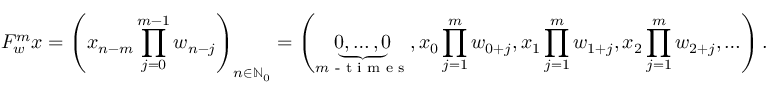Convert formula to latex. <formula><loc_0><loc_0><loc_500><loc_500>F _ { w } ^ { m } x = \left ( x _ { n - m } \prod _ { j = 0 } ^ { m - 1 } w _ { n - j } \right ) _ { n \in \mathbb { N } _ { 0 } } = \left ( \underbrace { 0 , \dots , 0 } _ { m - t i m e s } , x _ { 0 } \prod _ { j = 1 } ^ { m } w _ { 0 + j } , x _ { 1 } \prod _ { j = 1 } ^ { m } w _ { 1 + j } , x _ { 2 } \prod _ { j = 1 } ^ { m } w _ { 2 + j } , \dots \right ) .</formula> 